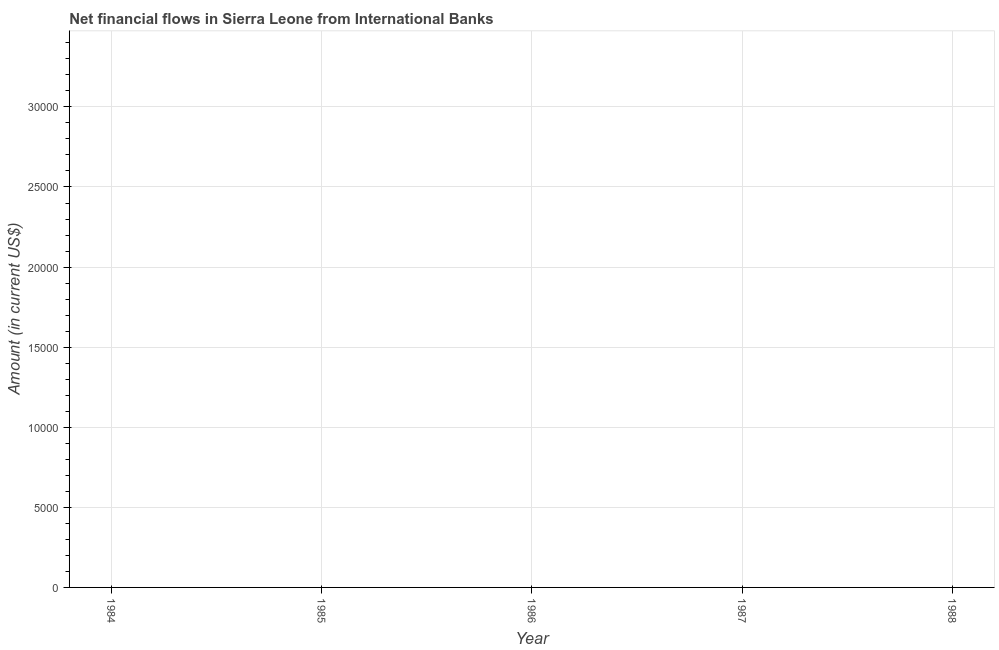What is the net financial flows from ibrd in 1985?
Ensure brevity in your answer.  0. Across all years, what is the minimum net financial flows from ibrd?
Your response must be concise. 0. What is the average net financial flows from ibrd per year?
Offer a terse response. 0. Does the net financial flows from ibrd monotonically increase over the years?
Offer a very short reply. No. How many lines are there?
Offer a very short reply. 0. What is the difference between two consecutive major ticks on the Y-axis?
Offer a terse response. 5000. What is the title of the graph?
Your response must be concise. Net financial flows in Sierra Leone from International Banks. What is the label or title of the X-axis?
Keep it short and to the point. Year. What is the Amount (in current US$) in 1985?
Provide a succinct answer. 0. What is the Amount (in current US$) of 1987?
Your answer should be compact. 0. 